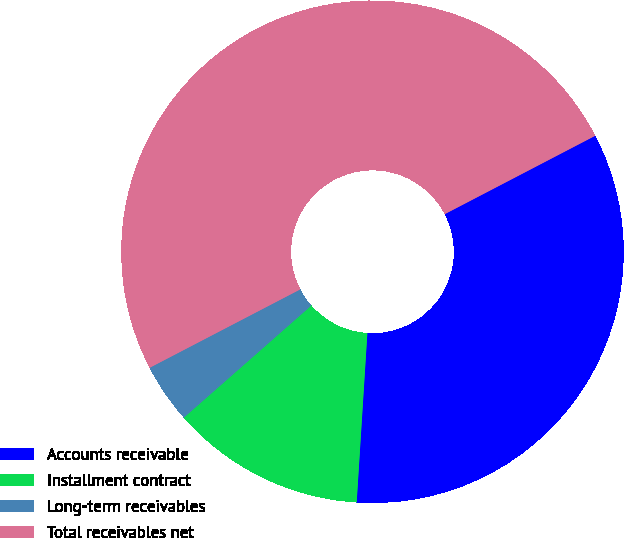<chart> <loc_0><loc_0><loc_500><loc_500><pie_chart><fcel>Accounts receivable<fcel>Installment contract<fcel>Long-term receivables<fcel>Total receivables net<nl><fcel>33.65%<fcel>12.52%<fcel>3.84%<fcel>50.0%<nl></chart> 